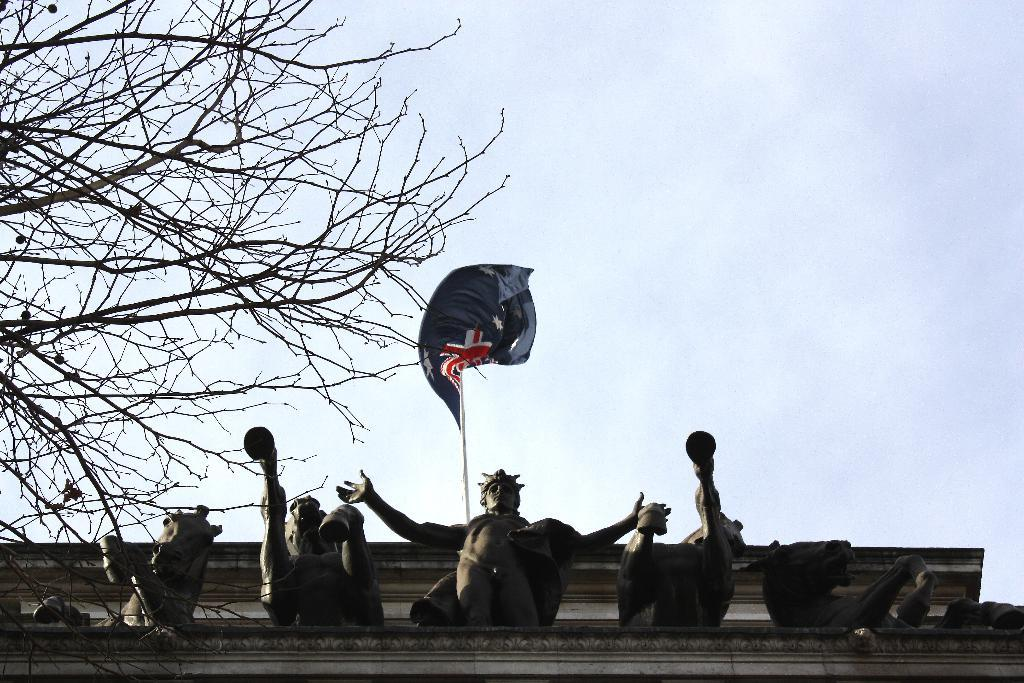What type of structure is present in the picture? There is a building in the picture. What decorative elements can be seen in the picture? There are statues in the picture. What is attached to the flag pole in the picture? There is a flag in the picture. What is the condition of the sky in the picture? The sky is clear in the picture. What type of cloth is being used topped with jelly in the picture? There is no cloth or jelly present in the picture; it features a building, statues, a flag pole, and a flag. 